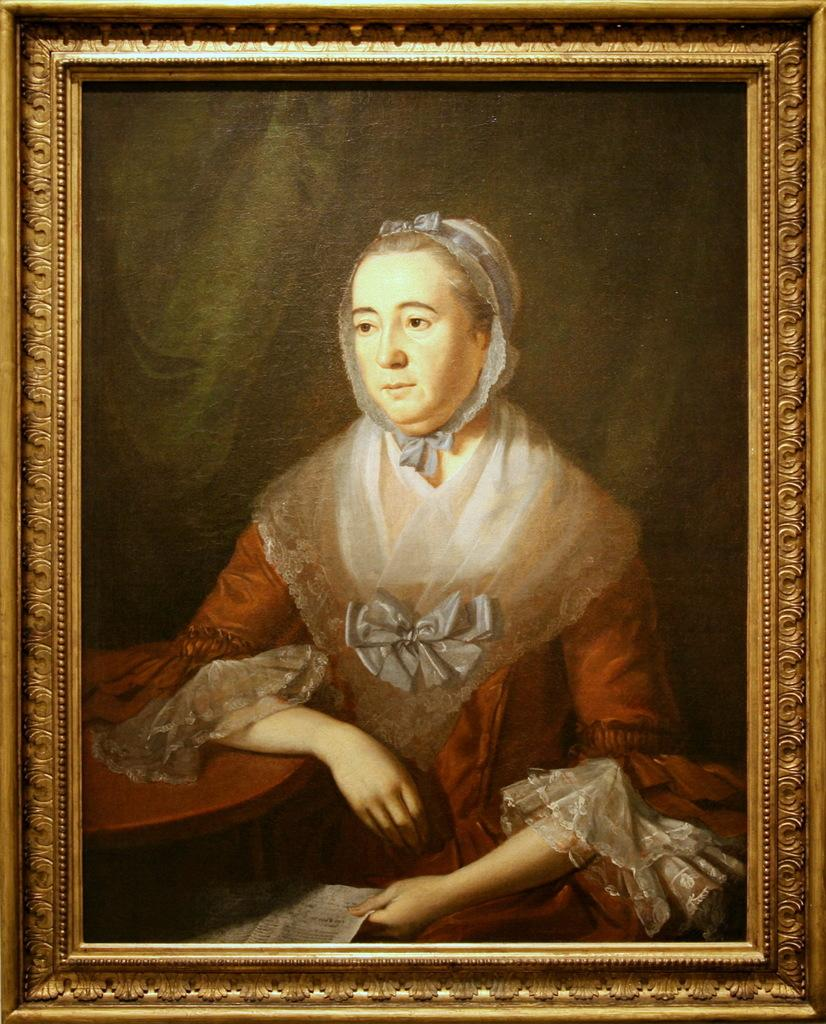What is the main subject of the image? The main subject of the image is a frame. What is depicted within the frame? A lady painting is present in the frame. What is the lady holding in the image? The lady is holding a paper. What is the lady wearing in the image? The lady is wearing a red and white color dress. How many snails can be seen crawling on the lady's dress in the image? There are no snails present in the image, so it is not possible to determine how many would be crawling on the lady's dress. 